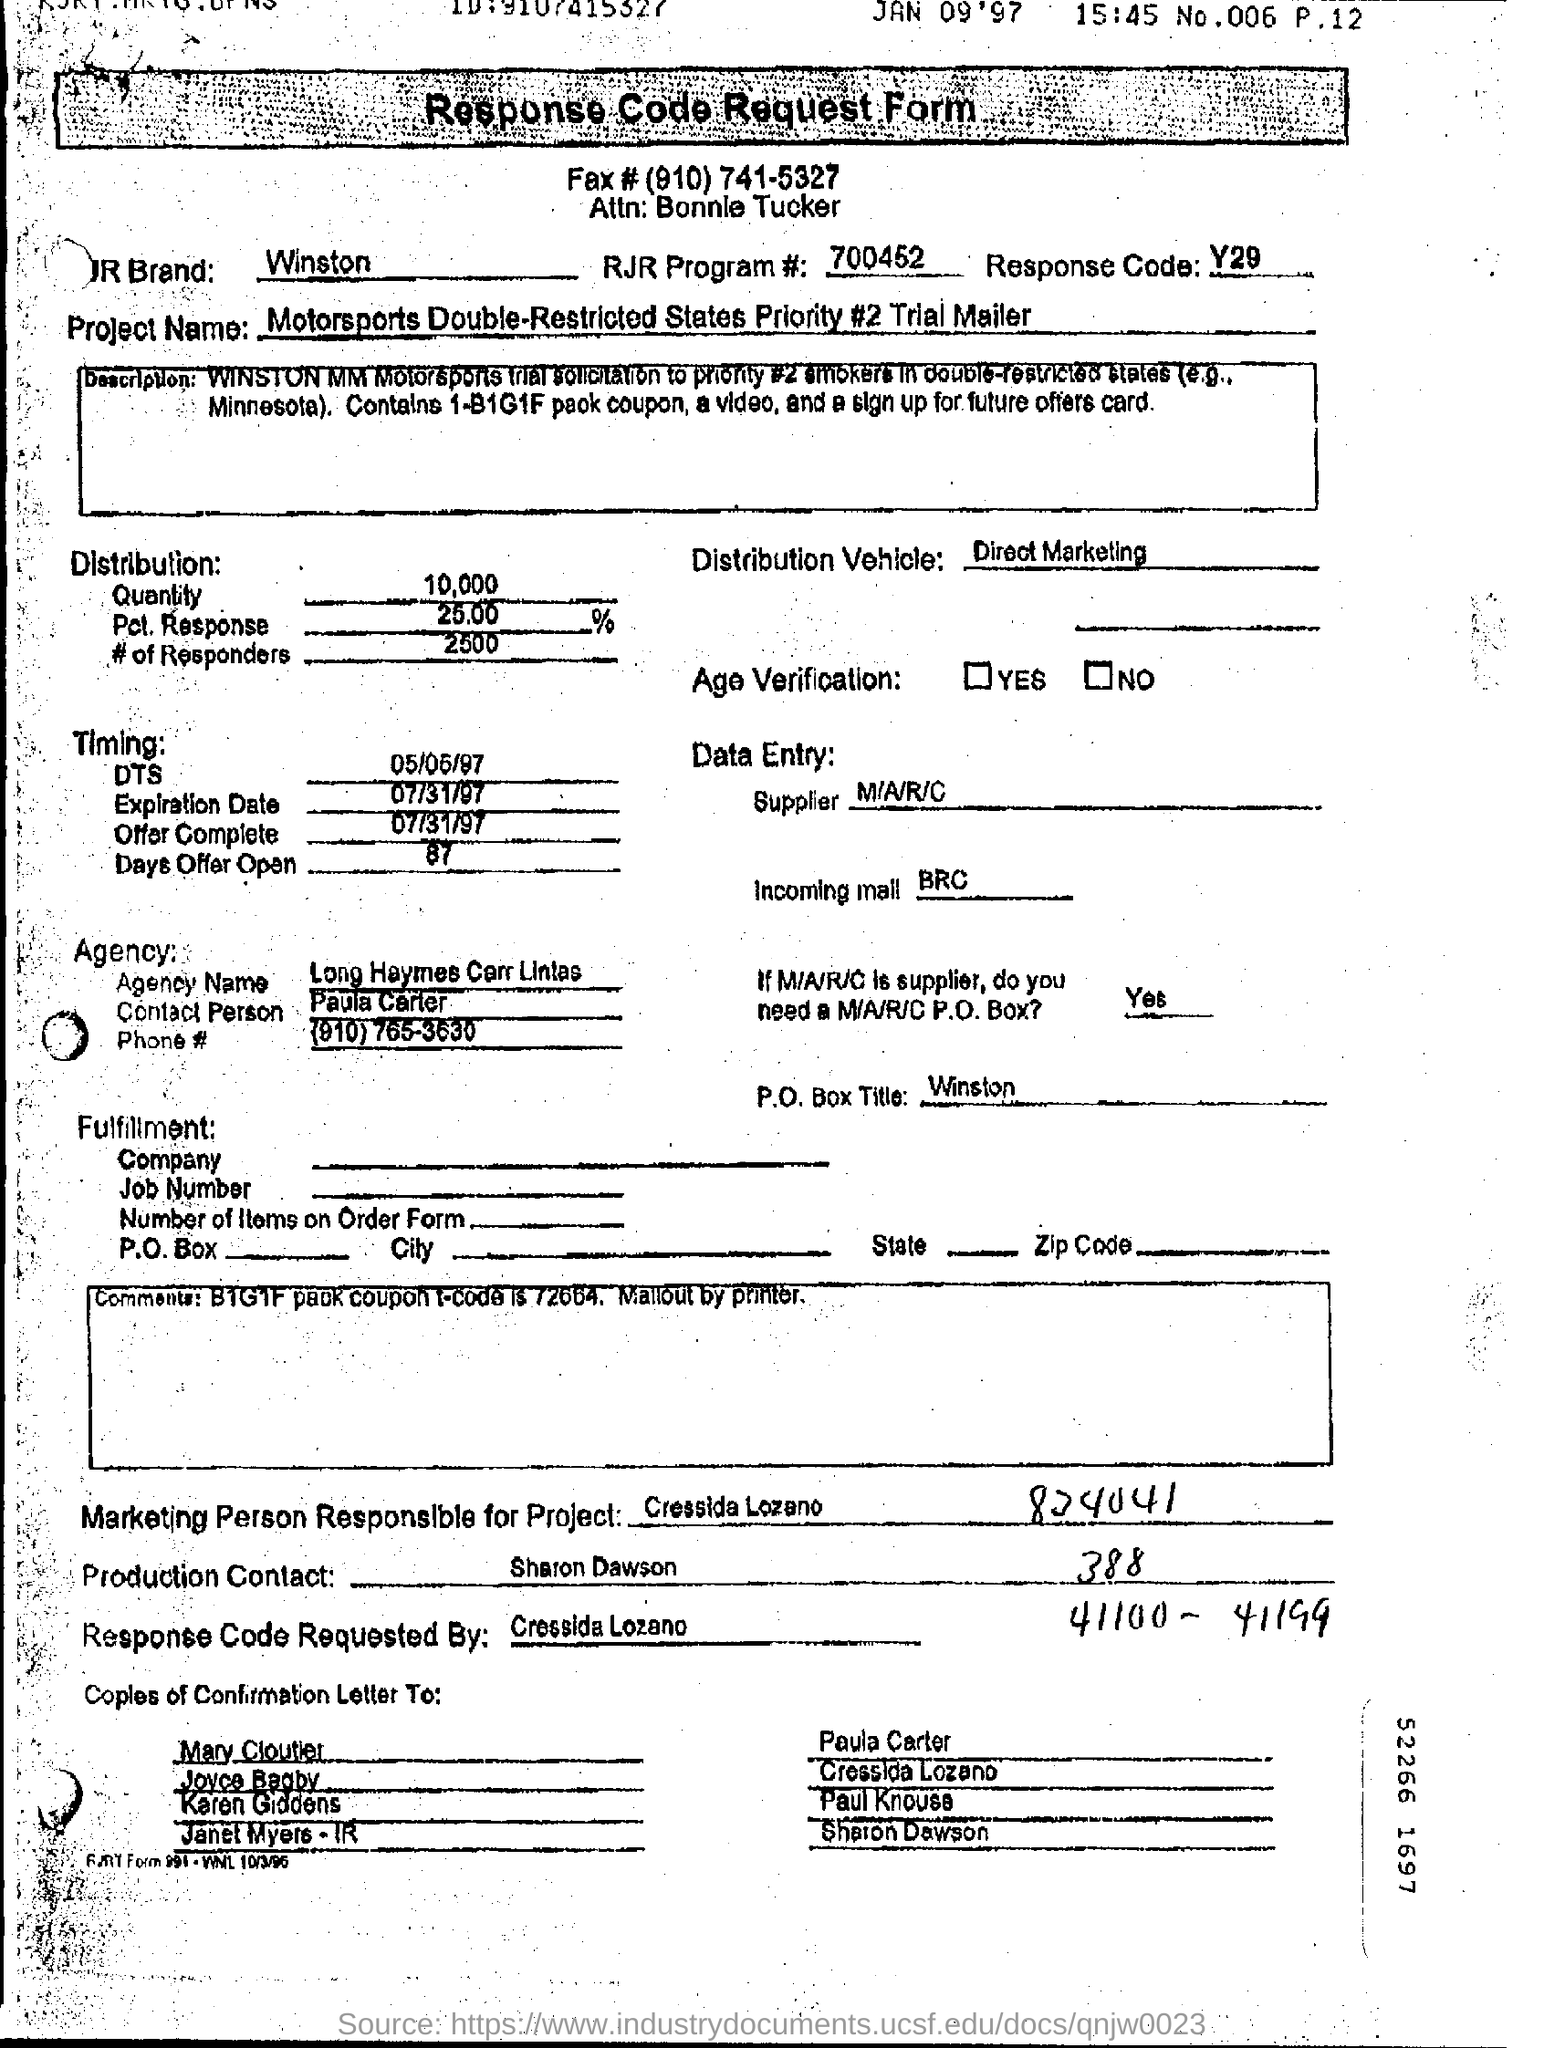List a handful of essential elements in this visual. The Agency Name is Long Haymes Carr Lintas. 